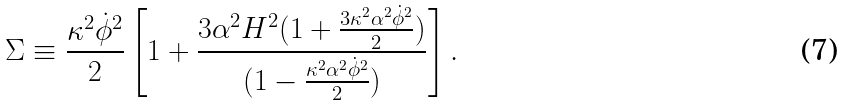Convert formula to latex. <formula><loc_0><loc_0><loc_500><loc_500>\Sigma \equiv \frac { \kappa ^ { 2 } \dot { \phi } ^ { 2 } } { 2 } \left [ 1 + \frac { 3 \alpha ^ { 2 } H ^ { 2 } ( 1 + \frac { 3 \kappa ^ { 2 } \alpha ^ { 2 } \dot { \phi } ^ { 2 } } { 2 } ) } { ( 1 - \frac { \kappa ^ { 2 } \alpha ^ { 2 } \dot { \phi } ^ { 2 } } { 2 } ) } \right ] .</formula> 